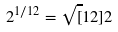Convert formula to latex. <formula><loc_0><loc_0><loc_500><loc_500>2 ^ { 1 / 1 2 } = \sqrt { [ } 1 2 ] { 2 }</formula> 